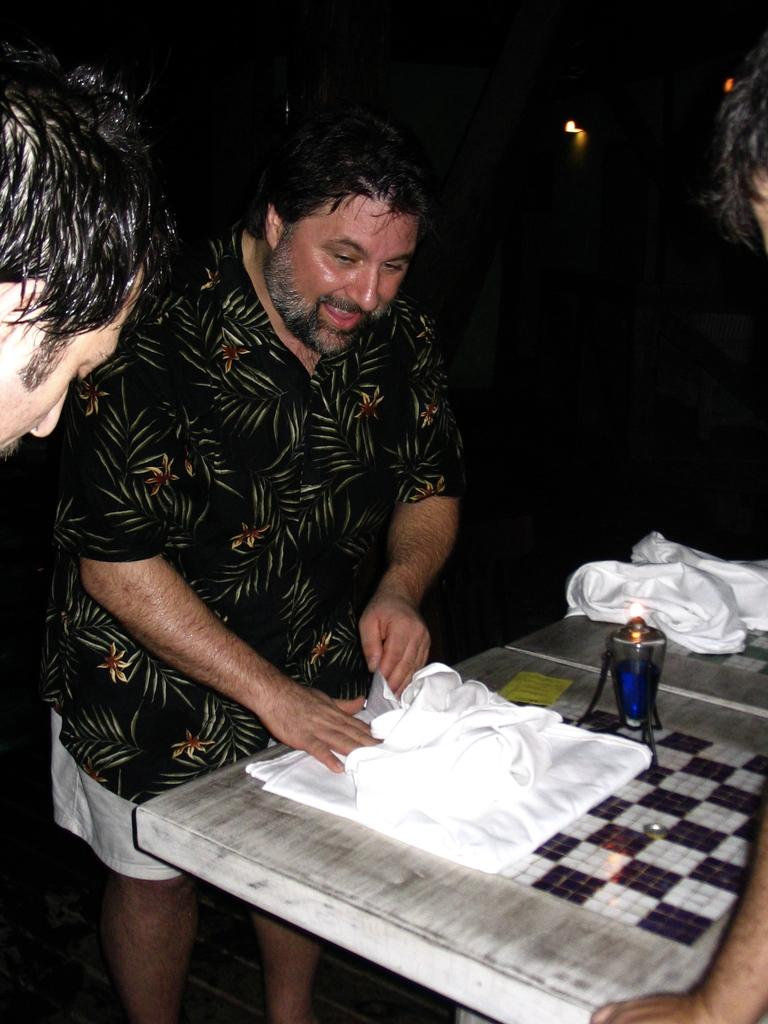What is happening in the image? There are people standing near a table in the image. What is on the table? There are clothes and objects on the table. Can you describe the background of the image? The background of the image is dark. What type of holiday is being celebrated in the image? There is no indication of a holiday being celebrated in the image. What color is the silverware on the table? There is no silverware present in the image. 